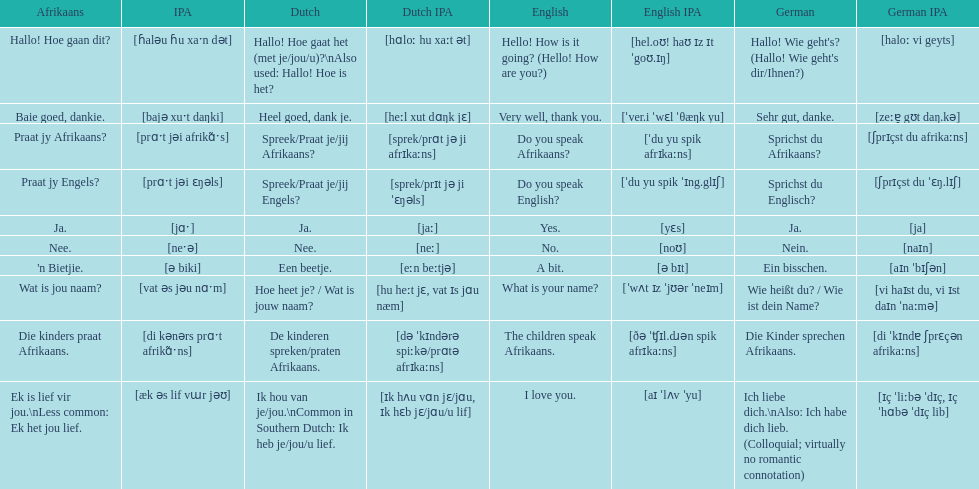Parse the full table. {'header': ['Afrikaans', 'IPA', 'Dutch', 'Dutch IPA', 'English', 'English IPA', 'German', 'German IPA'], 'rows': [['Hallo! Hoe gaan dit?', '[ɦaləu ɦu xaˑn dət]', 'Hallo! Hoe gaat het (met je/jou/u)?\\nAlso used: Hallo! Hoe is het?', '[hɑloː hu xaːt ət]', 'Hello! How is it going? (Hello! How are you?)', '[hel.oʊ! haʊ ɪz ɪt ˈgoʊ.ɪŋ]', "Hallo! Wie geht's? (Hallo! Wie geht's dir/Ihnen?)", '[haloː vi geyts]'], ['Baie goed, dankie.', '[bajə xuˑt daŋki]', 'Heel goed, dank je.', '[heːl xut dɑŋk jɛ]', 'Very well, thank you.', '[ˈver.i ˈwɛl ˈθæŋk yu]', 'Sehr gut, danke.', '[zeːɐ̯ gʊt daŋ.kə]'], ['Praat jy Afrikaans?', '[prɑˑt jəi afrikɑ̃ˑs]', 'Spreek/Praat je/jij Afrikaans?', '[sprek/prɑt jə ji afrɪkaːns]', 'Do you speak Afrikaans?', '[ˈdu yu spik afrɪkaːns]', 'Sprichst du Afrikaans?', '[ʃprɪçst du afrikaːns]'], ['Praat jy Engels?', '[prɑˑt jəi ɛŋəls]', 'Spreek/Praat je/jij Engels?', '[sprek/prɪt jə ji ˈɛŋəls]', 'Do you speak English?', '[ˈdu yu spik ˈɪng.glɪʃ]', 'Sprichst du Englisch?', '[ʃprɪçst du ˈɛŋ.lɪʃ]'], ['Ja.', '[jɑˑ]', 'Ja.', '[jaː]', 'Yes.', '[yɛs]', 'Ja.', '[ja]'], ['Nee.', '[neˑə]', 'Nee.', '[neː]', 'No.', '[noʊ]', 'Nein.', '[naɪn]'], ["'n Bietjie.", '[ə biki]', 'Een beetje.', '[eːn beːtjə]', 'A bit.', '[ə bɪt]', 'Ein bisschen.', '[aɪn ˈbɪʃən]'], ['Wat is jou naam?', '[vat əs jəu nɑˑm]', 'Hoe heet je? / Wat is jouw naam?', '[hu heːt jɛ, vat ɪs jɑu næm]', 'What is your name?', '[ˈwʌt ɪz ˈjʊər ˈneɪm]', 'Wie heißt du? / Wie ist dein Name?', '[vi haɪst du, vi ɪst daɪn ˈnaːmə]'], ['Die kinders praat Afrikaans.', '[di kənərs prɑˑt afrikɑ̃ˑns]', 'De kinderen spreken/praten Afrikaans.', '[də ˈkɪndərə spiːkə/prɑtə afrɪkaːns]', 'The children speak Afrikaans.', '[ðə ˈʧɪl.dɹən spik afrɪkaːns]', 'Die Kinder sprechen Afrikaans.', '[di ˈkɪndɐ ʃprɛçən afrikaːns]'], ['Ek is lief vir jou.\\nLess common: Ek het jou lief.', '[æk əs lif vɯr jəʊ]', 'Ik hou van je/jou.\\nCommon in Southern Dutch: Ik heb je/jou/u lief.', '[ɪk hʌu vɑn jɛ/jɑu, ɪk hɛb jɛ/jɑu/u lif]', 'I love you.', '[aɪ ˈlʌv ˈyu]', 'Ich liebe dich.\\nAlso: Ich habe dich lieb. (Colloquial; virtually no romantic connotation)', '[ɪç ˈliːbə ˈdɪç, ɪç ˈhɑbə ˈdɪç lib]']]} How do you say 'i love you' in afrikaans? Ek is lief vir jou. 